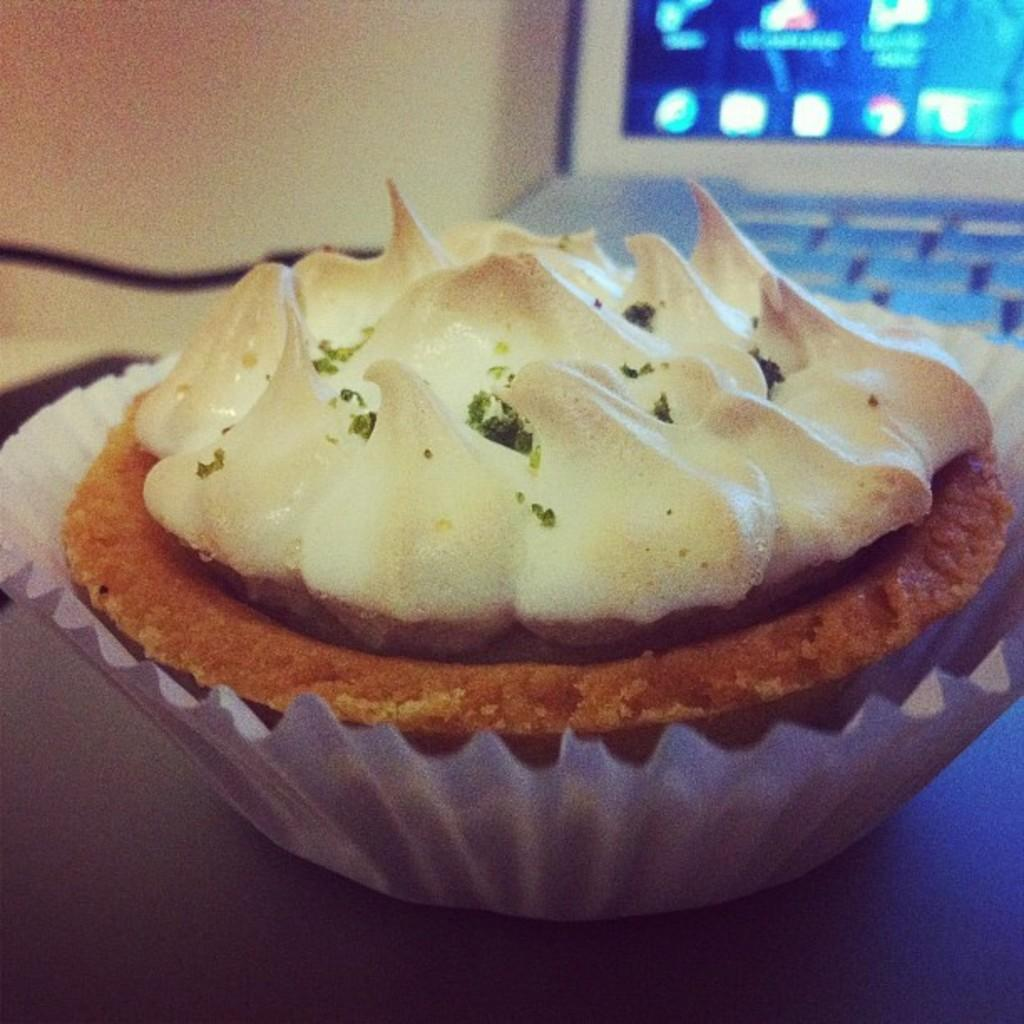What is placed on the table in the image? There is a cupcake placed on a table. What can be seen in the background of the image? There is a laptop visible in the background. What type of thunder can be heard coming from the cup in the image? There is no cup or thunder present in the image; it features a cupcake placed on a table and a laptop visible in the background. 